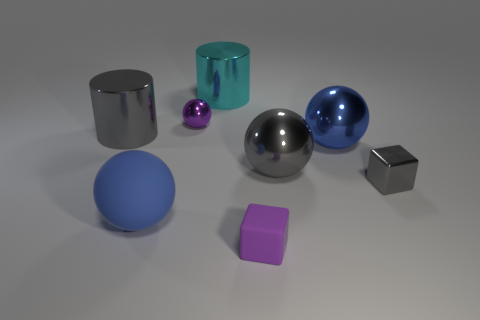Is the number of purple rubber cubes greater than the number of blue shiny cubes?
Offer a terse response. Yes. Is the cyan cylinder made of the same material as the large gray cylinder?
Your answer should be very brief. Yes. What shape is the cyan thing that is the same material as the gray cylinder?
Offer a very short reply. Cylinder. Are there fewer purple matte balls than large cyan metal cylinders?
Your response must be concise. Yes. What is the material of the gray thing that is both on the right side of the gray cylinder and on the left side of the large blue metallic object?
Provide a short and direct response. Metal. There is a metal cylinder to the right of the large gray object on the left side of the large blue thing that is on the left side of the large cyan cylinder; how big is it?
Provide a succinct answer. Large. Do the tiny gray object and the tiny metal object behind the big gray metallic ball have the same shape?
Offer a very short reply. No. What number of big metal things are behind the small metallic sphere and left of the large cyan shiny cylinder?
Keep it short and to the point. 0. How many purple things are cylinders or blocks?
Your response must be concise. 1. Do the shiny cylinder in front of the cyan shiny thing and the small shiny object to the right of the cyan object have the same color?
Your answer should be very brief. Yes. 